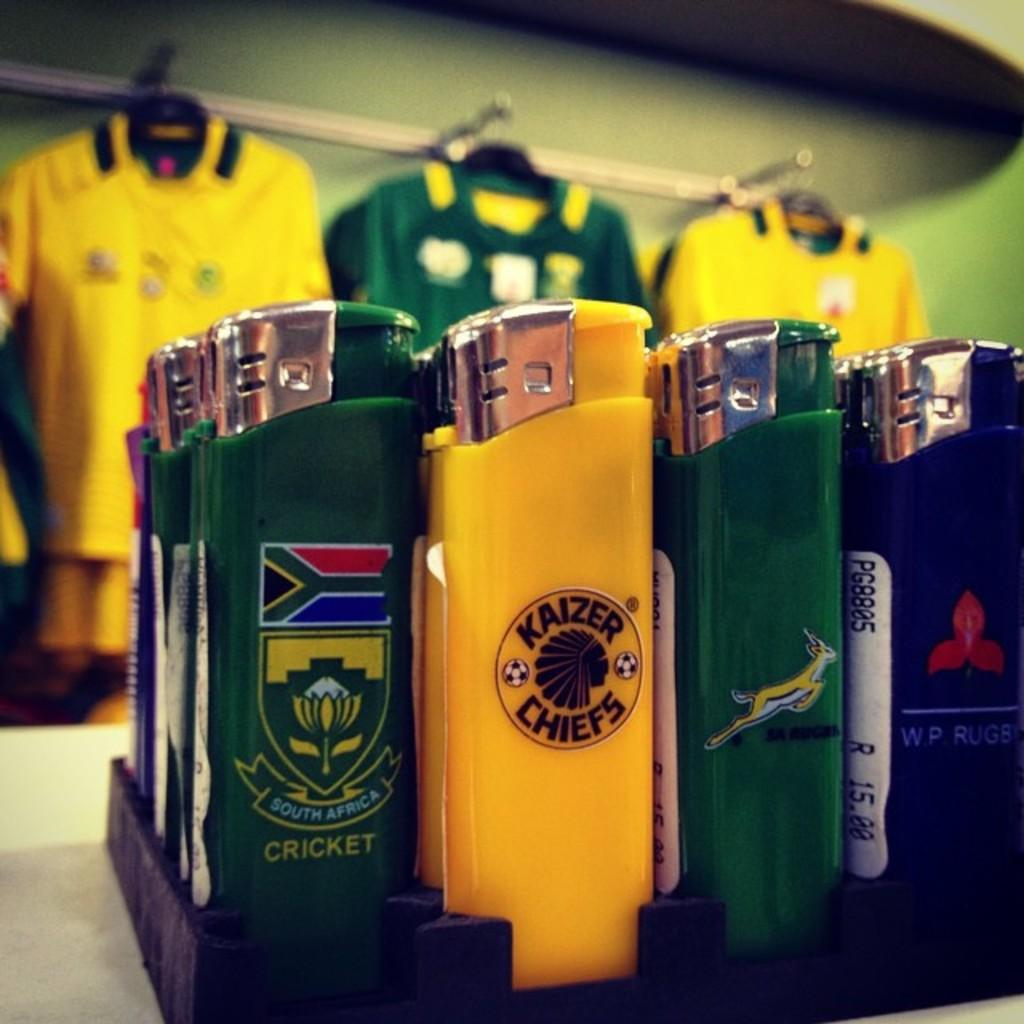What can be seen in the image that comes in different colors? There are liters of different colors in the image. What type of clothing items are present in the image? T-shirts are hanging on hangers in the image. Can you describe the background of the image? The background of the image is slightly blurred. Where is the lunchroom located in the image? There is no lunchroom present in the image. What type of linen is draped over the T-shirts in the image? There is no linen present in the image; only T-shirts hanging on hangers are visible. 